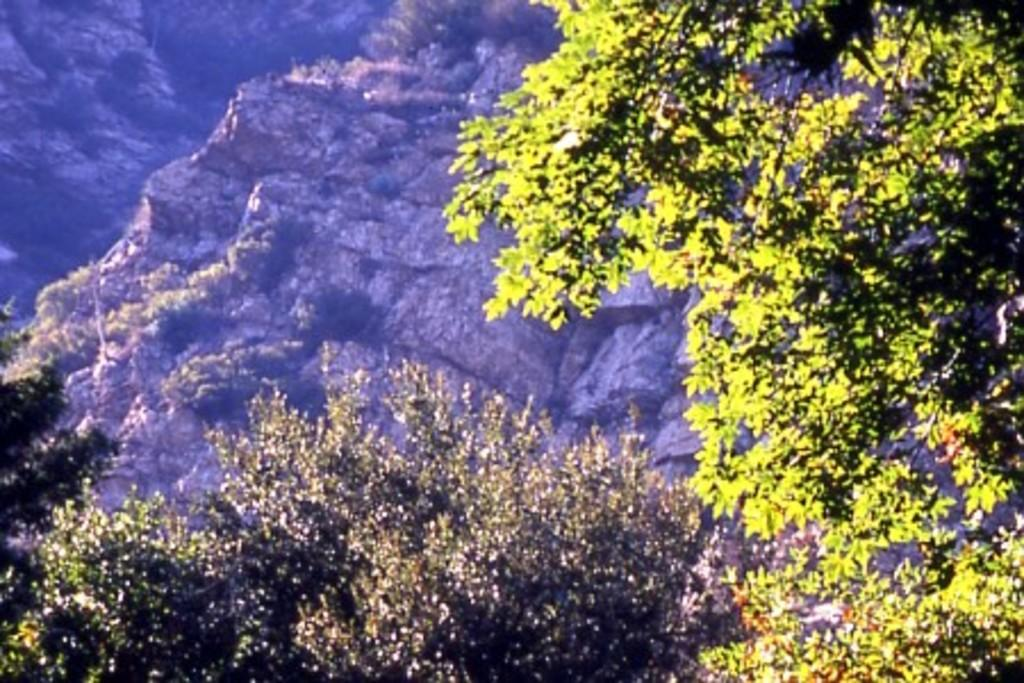What type of vegetation can be seen in the image? There are trees in the image. What geographical features are present in the image? There are hills in the image. What type of cough can be heard in the image? There is no sound or indication of a cough in the image. What substance is being used to paint the trees in the image? There is no painting or substance mentioned in the image; it simply shows trees and hills. 